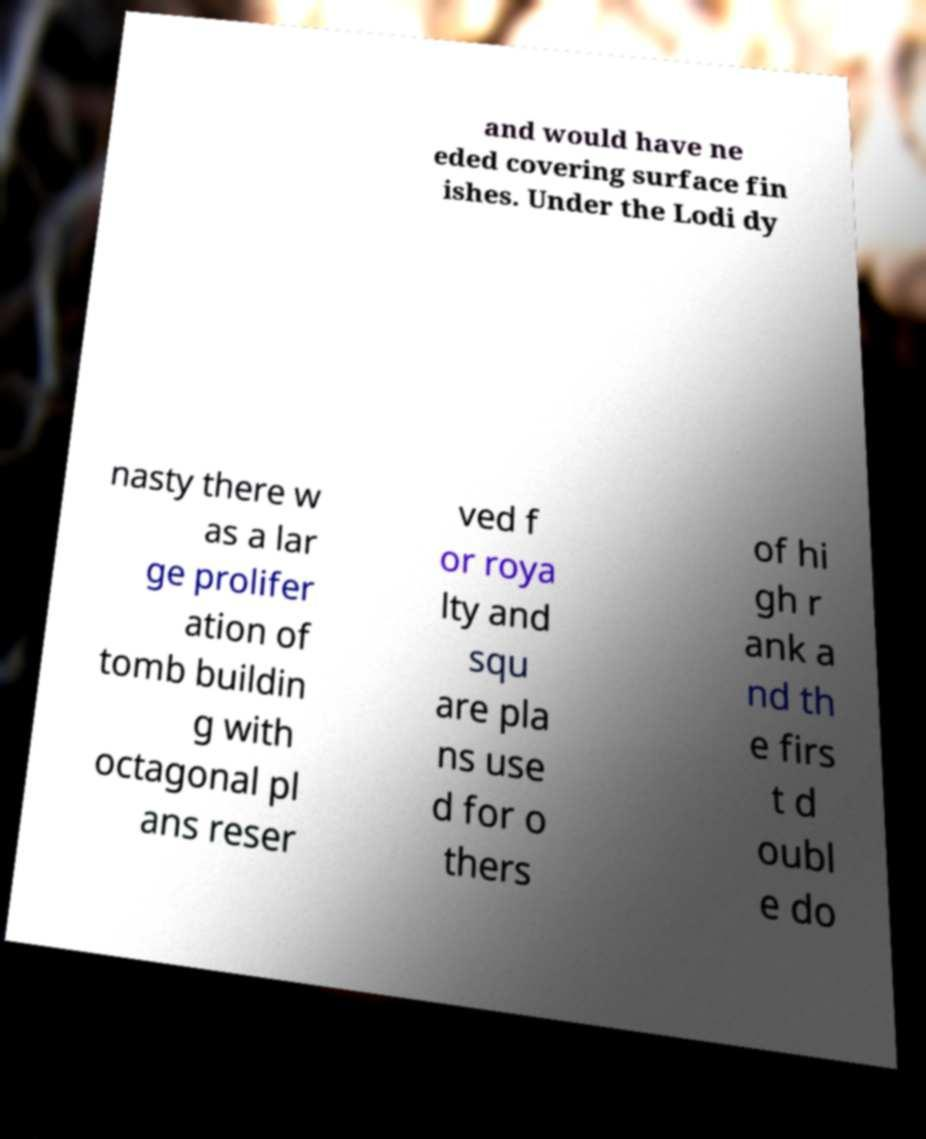I need the written content from this picture converted into text. Can you do that? and would have ne eded covering surface fin ishes. Under the Lodi dy nasty there w as a lar ge prolifer ation of tomb buildin g with octagonal pl ans reser ved f or roya lty and squ are pla ns use d for o thers of hi gh r ank a nd th e firs t d oubl e do 